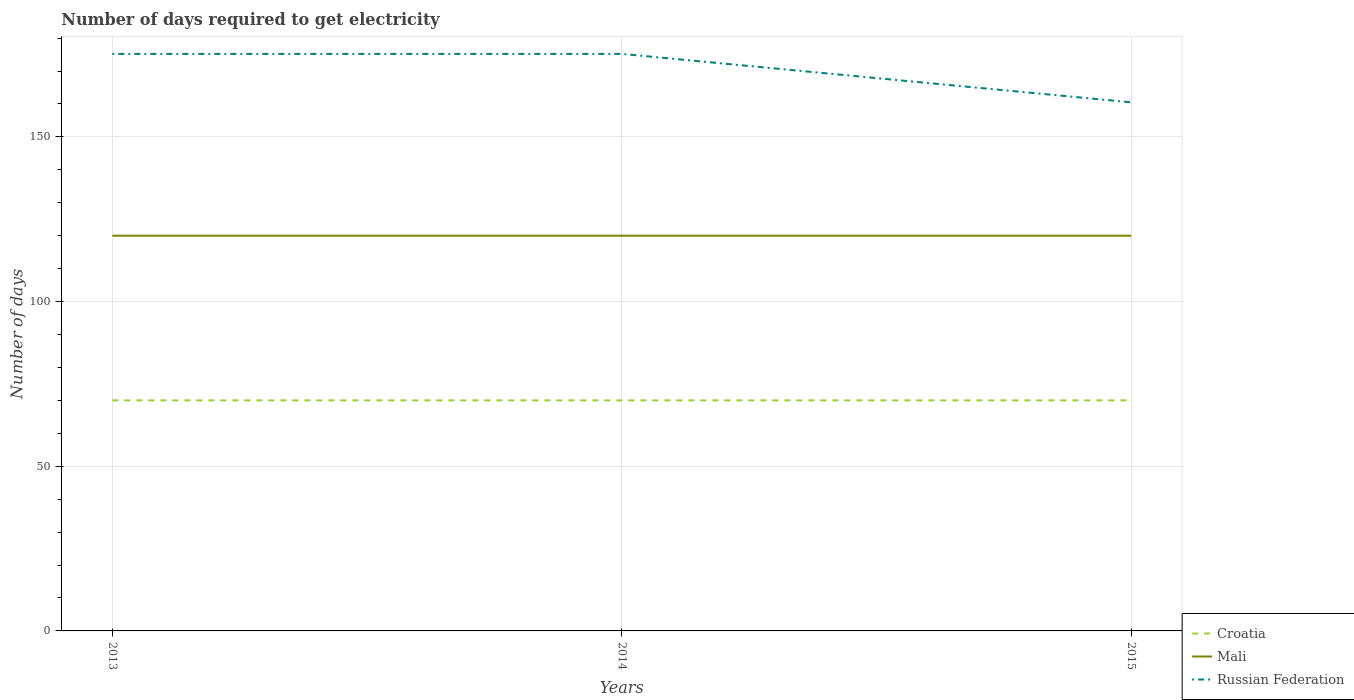How many different coloured lines are there?
Give a very brief answer. 3. Across all years, what is the maximum number of days required to get electricity in in Russian Federation?
Offer a very short reply. 160.5. In which year was the number of days required to get electricity in in Russian Federation maximum?
Keep it short and to the point. 2015. What is the difference between the highest and the second highest number of days required to get electricity in in Russian Federation?
Make the answer very short. 14.7. How many lines are there?
Your answer should be very brief. 3. Does the graph contain any zero values?
Give a very brief answer. No. Does the graph contain grids?
Provide a short and direct response. Yes. How many legend labels are there?
Your response must be concise. 3. How are the legend labels stacked?
Give a very brief answer. Vertical. What is the title of the graph?
Your response must be concise. Number of days required to get electricity. Does "Armenia" appear as one of the legend labels in the graph?
Give a very brief answer. No. What is the label or title of the Y-axis?
Make the answer very short. Number of days. What is the Number of days of Croatia in 2013?
Offer a very short reply. 70. What is the Number of days of Mali in 2013?
Offer a terse response. 120. What is the Number of days of Russian Federation in 2013?
Your answer should be compact. 175.2. What is the Number of days in Croatia in 2014?
Give a very brief answer. 70. What is the Number of days of Mali in 2014?
Ensure brevity in your answer.  120. What is the Number of days in Russian Federation in 2014?
Make the answer very short. 175.2. What is the Number of days in Mali in 2015?
Your answer should be compact. 120. What is the Number of days of Russian Federation in 2015?
Provide a succinct answer. 160.5. Across all years, what is the maximum Number of days of Croatia?
Give a very brief answer. 70. Across all years, what is the maximum Number of days in Mali?
Ensure brevity in your answer.  120. Across all years, what is the maximum Number of days in Russian Federation?
Ensure brevity in your answer.  175.2. Across all years, what is the minimum Number of days of Mali?
Your response must be concise. 120. Across all years, what is the minimum Number of days in Russian Federation?
Offer a very short reply. 160.5. What is the total Number of days in Croatia in the graph?
Give a very brief answer. 210. What is the total Number of days of Mali in the graph?
Your answer should be compact. 360. What is the total Number of days in Russian Federation in the graph?
Offer a very short reply. 510.9. What is the difference between the Number of days in Croatia in 2013 and that in 2014?
Provide a succinct answer. 0. What is the difference between the Number of days in Croatia in 2013 and that in 2015?
Make the answer very short. 0. What is the difference between the Number of days in Mali in 2013 and that in 2015?
Your answer should be very brief. 0. What is the difference between the Number of days of Russian Federation in 2013 and that in 2015?
Your answer should be very brief. 14.7. What is the difference between the Number of days of Mali in 2014 and that in 2015?
Your response must be concise. 0. What is the difference between the Number of days in Russian Federation in 2014 and that in 2015?
Offer a terse response. 14.7. What is the difference between the Number of days of Croatia in 2013 and the Number of days of Russian Federation in 2014?
Provide a short and direct response. -105.2. What is the difference between the Number of days of Mali in 2013 and the Number of days of Russian Federation in 2014?
Make the answer very short. -55.2. What is the difference between the Number of days of Croatia in 2013 and the Number of days of Russian Federation in 2015?
Your answer should be compact. -90.5. What is the difference between the Number of days of Mali in 2013 and the Number of days of Russian Federation in 2015?
Your answer should be very brief. -40.5. What is the difference between the Number of days of Croatia in 2014 and the Number of days of Mali in 2015?
Your response must be concise. -50. What is the difference between the Number of days in Croatia in 2014 and the Number of days in Russian Federation in 2015?
Keep it short and to the point. -90.5. What is the difference between the Number of days of Mali in 2014 and the Number of days of Russian Federation in 2015?
Your answer should be compact. -40.5. What is the average Number of days in Mali per year?
Your answer should be very brief. 120. What is the average Number of days of Russian Federation per year?
Provide a succinct answer. 170.3. In the year 2013, what is the difference between the Number of days of Croatia and Number of days of Mali?
Ensure brevity in your answer.  -50. In the year 2013, what is the difference between the Number of days in Croatia and Number of days in Russian Federation?
Keep it short and to the point. -105.2. In the year 2013, what is the difference between the Number of days of Mali and Number of days of Russian Federation?
Offer a terse response. -55.2. In the year 2014, what is the difference between the Number of days of Croatia and Number of days of Russian Federation?
Give a very brief answer. -105.2. In the year 2014, what is the difference between the Number of days in Mali and Number of days in Russian Federation?
Ensure brevity in your answer.  -55.2. In the year 2015, what is the difference between the Number of days in Croatia and Number of days in Mali?
Offer a very short reply. -50. In the year 2015, what is the difference between the Number of days in Croatia and Number of days in Russian Federation?
Your answer should be compact. -90.5. In the year 2015, what is the difference between the Number of days in Mali and Number of days in Russian Federation?
Make the answer very short. -40.5. What is the ratio of the Number of days of Croatia in 2013 to that in 2014?
Offer a terse response. 1. What is the ratio of the Number of days in Mali in 2013 to that in 2014?
Give a very brief answer. 1. What is the ratio of the Number of days in Russian Federation in 2013 to that in 2014?
Keep it short and to the point. 1. What is the ratio of the Number of days of Mali in 2013 to that in 2015?
Keep it short and to the point. 1. What is the ratio of the Number of days in Russian Federation in 2013 to that in 2015?
Your response must be concise. 1.09. What is the ratio of the Number of days of Mali in 2014 to that in 2015?
Offer a terse response. 1. What is the ratio of the Number of days in Russian Federation in 2014 to that in 2015?
Give a very brief answer. 1.09. What is the difference between the highest and the second highest Number of days of Russian Federation?
Make the answer very short. 0. 